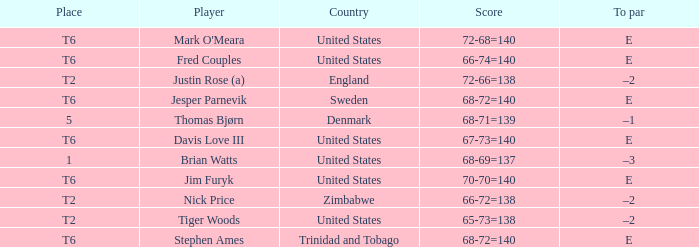What was the TO par for the player who scored 68-69=137? –3. 